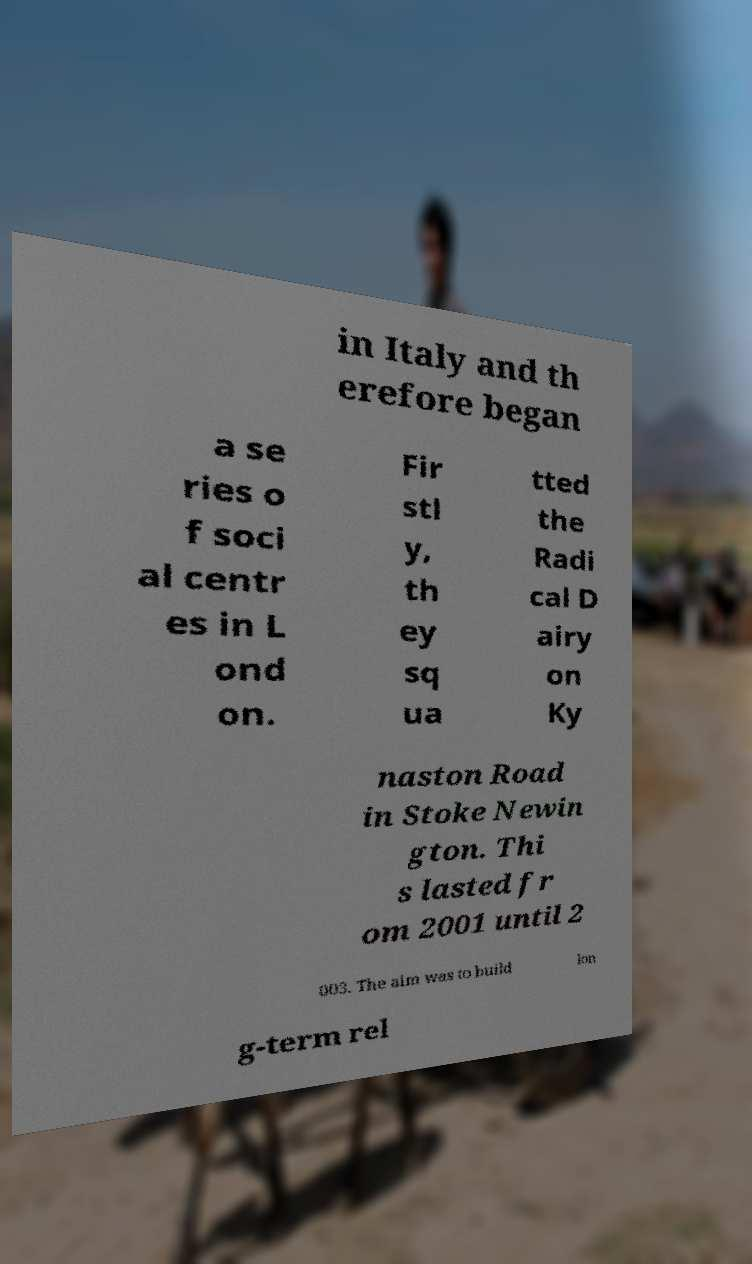Could you assist in decoding the text presented in this image and type it out clearly? in Italy and th erefore began a se ries o f soci al centr es in L ond on. Fir stl y, th ey sq ua tted the Radi cal D airy on Ky naston Road in Stoke Newin gton. Thi s lasted fr om 2001 until 2 003. The aim was to build lon g-term rel 